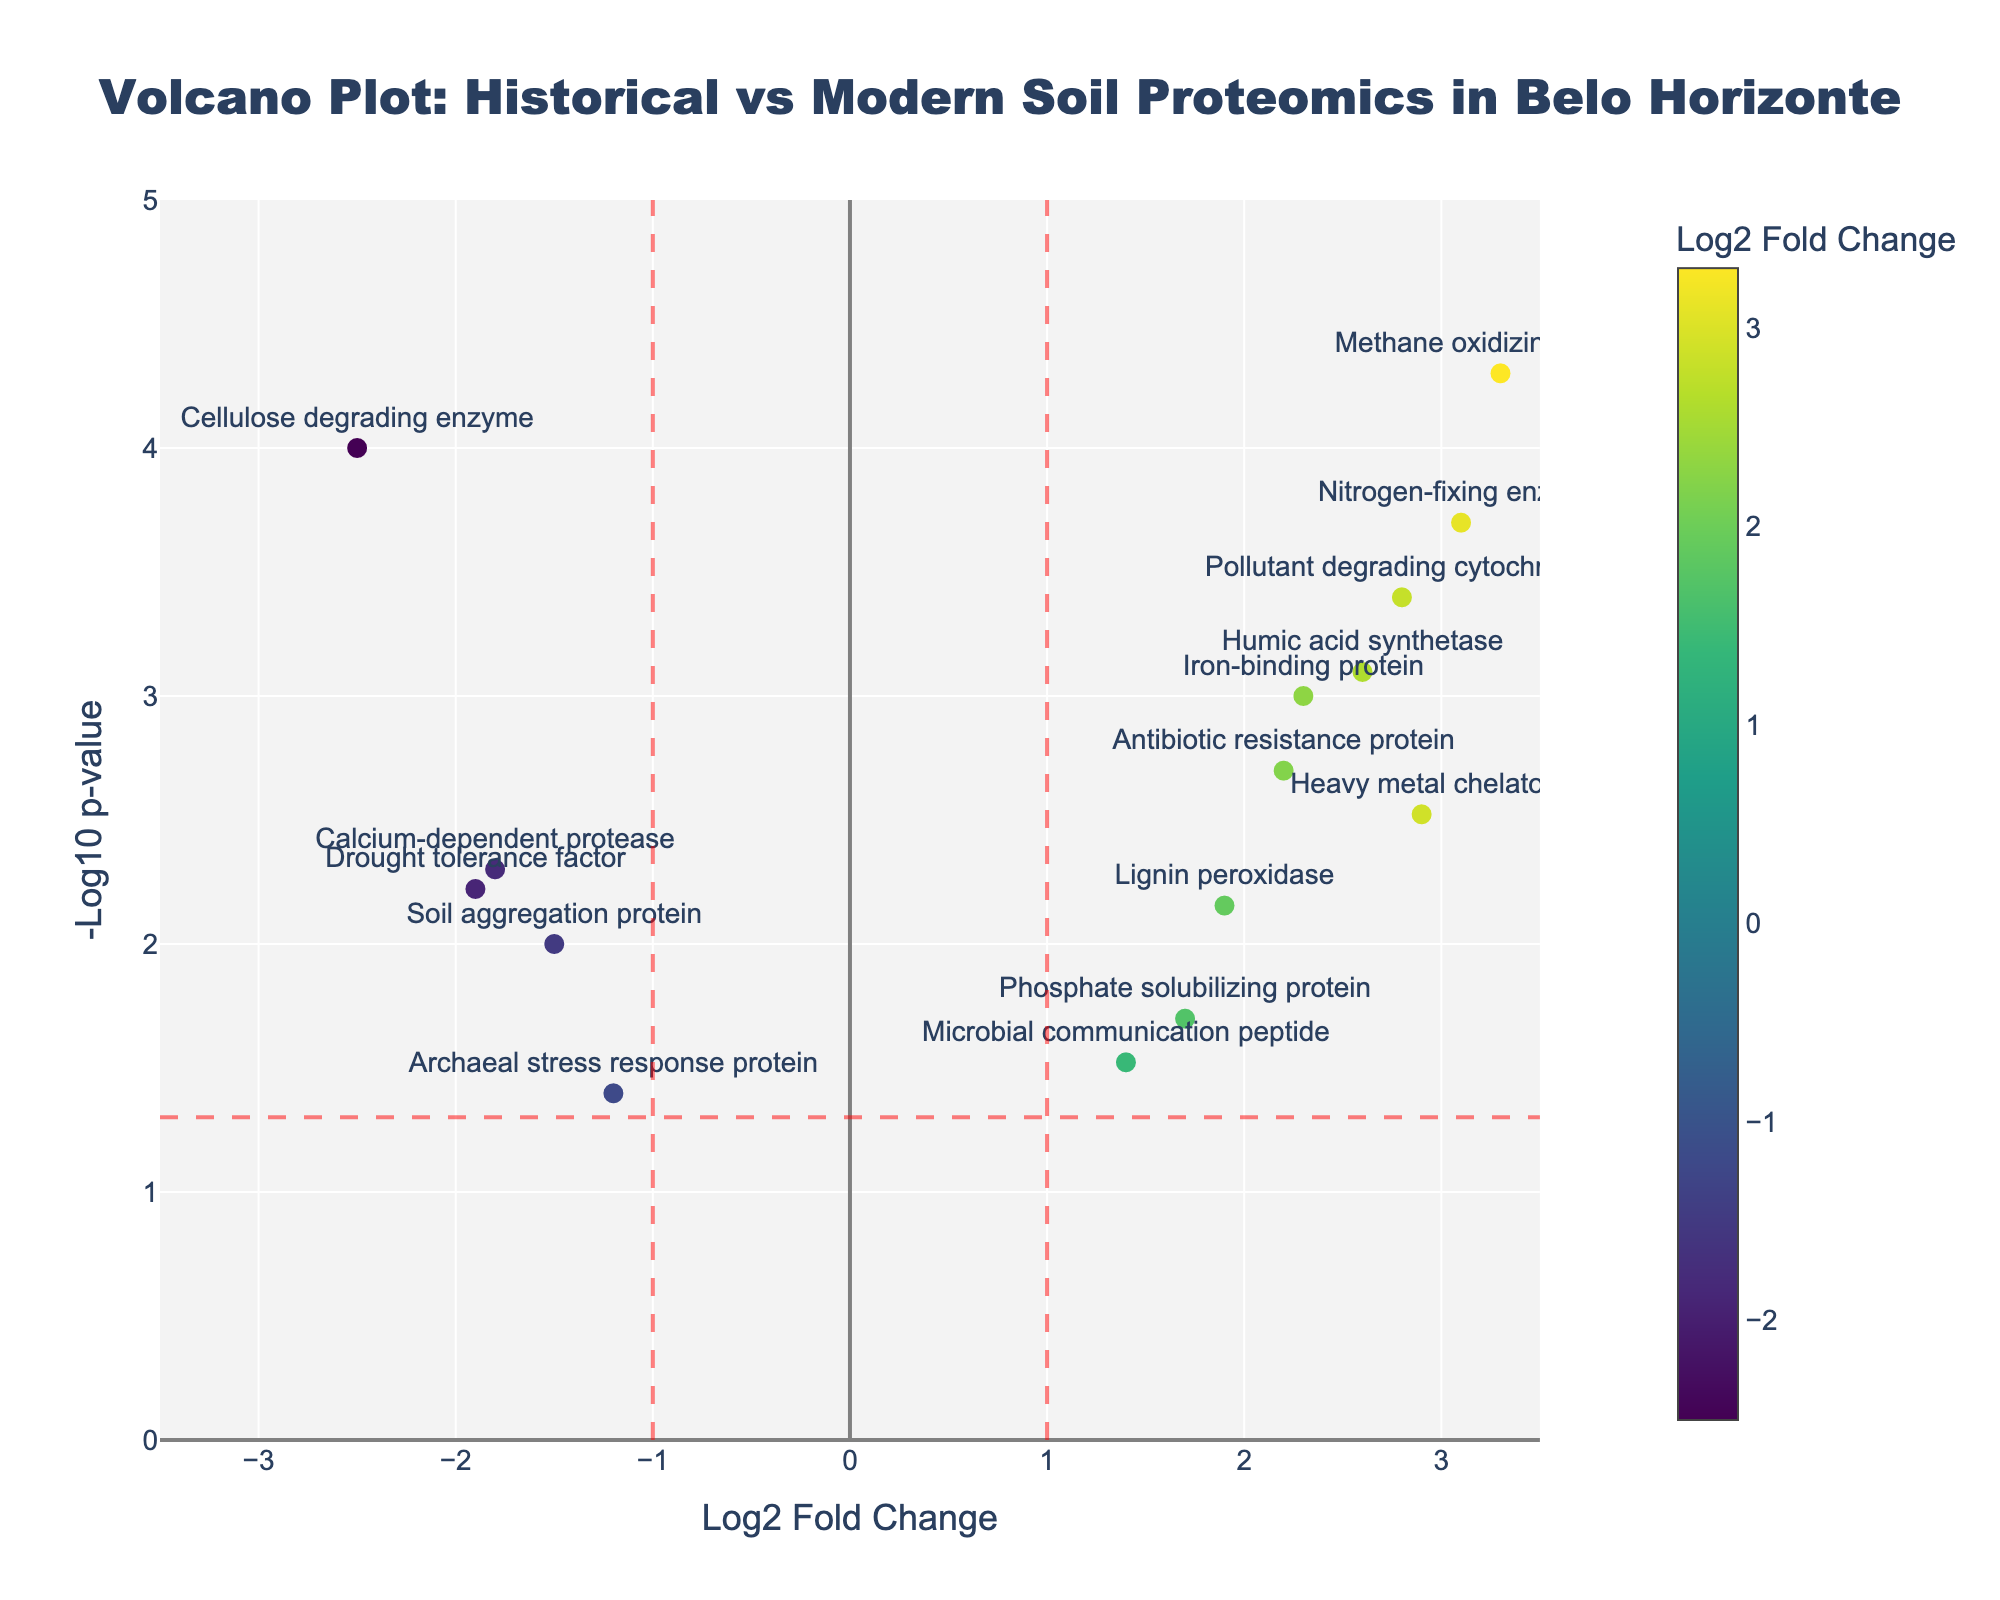How many data points are in the volcano plot? There are 15 rows in the data, each representing a unique protein, which means there are 15 data points in the plot.
Answer: 15 What is the title of the plot? The title is displayed at the top of the plot.
Answer: Volcano Plot: Historical vs Modern Soil Proteomics in Belo Horizonte What does the color of the data points represent? The color scale on the right of the plot indicates that the colors represent Log2 Fold Change values.
Answer: Log2 Fold Change What are the x-axis and y-axis labels? The labels are specified at the bottom and left side of the plot.
Answer: Log2 Fold Change and -Log10 p-value Which protein has the highest Log2 fold change? By finding the data point with the maximum value on the x-axis (Log2 Fold Change), the protein is identified as Methane oxidizing enzyme.
Answer: Methane oxidizing enzyme How many proteins have a significant p-value (< 0.05)? The horizontal red dashed line represents a p-value of 0.05 (-Log10 p-value = 1.3). Count the points above this line to find the number of proteins.
Answer: 11 Which protein has the lowest p-value? The lowest p-value corresponds to the highest -Log10 p-value on the y-axis. This protein is identified by hovering over the highest data point or seeing from the data.
Answer: Methane oxidizing enzyme How many proteins have a Log2 fold change greater than 1? By observing the data points to the right of the vertical red line at x=1, we count the number of proteins.
Answer: 7 Are there any proteins with a negative Log2 fold change that are also statistically significant? Identify the data points to the left of the vertical red line at x=-1, and count those above the horizontal red line.
Answer: 4 Compare the p-values of Iron-binding protein and Pollutant degrading cytochrome. Which one is smaller? Locate both proteins on the plot and compare their y-axis (-Log10 p-value) positions.
Answer: Pollutant degrading cytochrome 